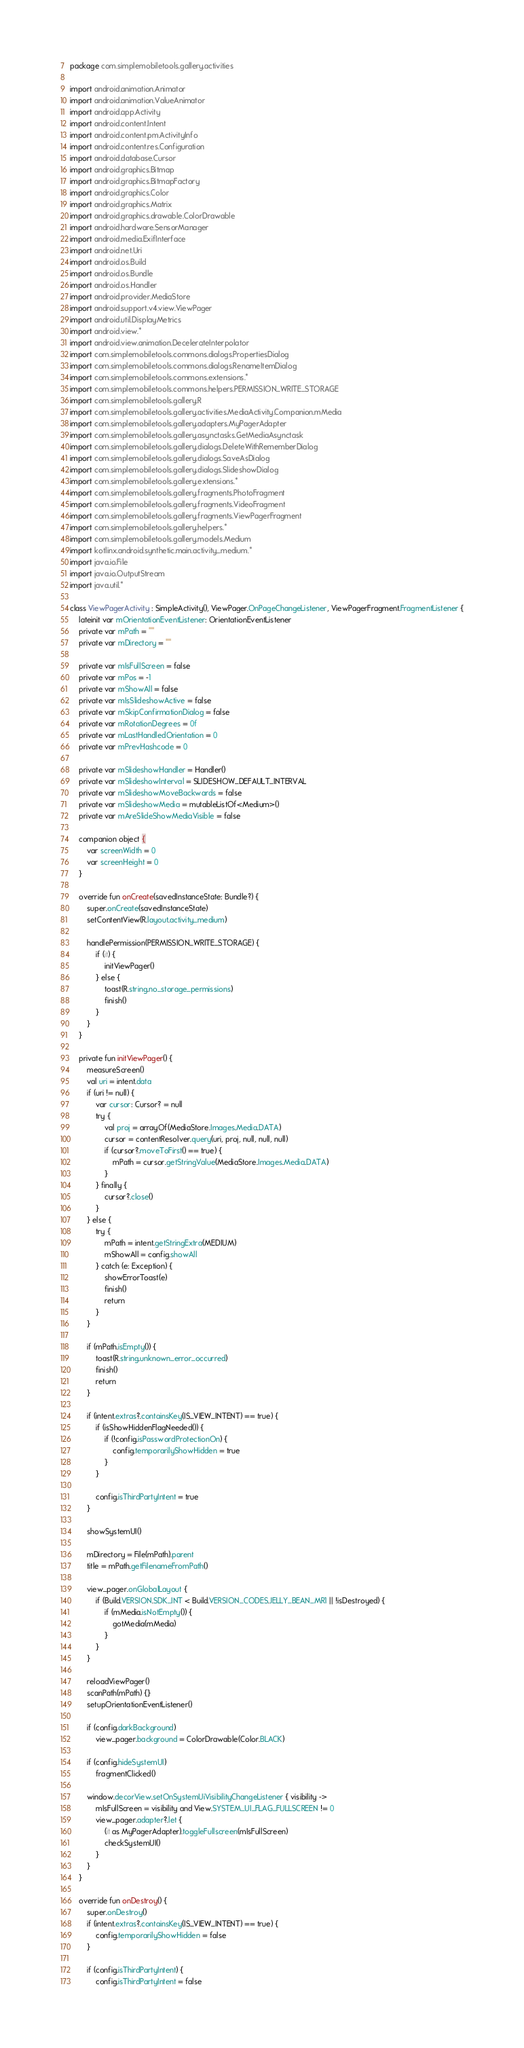Convert code to text. <code><loc_0><loc_0><loc_500><loc_500><_Kotlin_>package com.simplemobiletools.gallery.activities

import android.animation.Animator
import android.animation.ValueAnimator
import android.app.Activity
import android.content.Intent
import android.content.pm.ActivityInfo
import android.content.res.Configuration
import android.database.Cursor
import android.graphics.Bitmap
import android.graphics.BitmapFactory
import android.graphics.Color
import android.graphics.Matrix
import android.graphics.drawable.ColorDrawable
import android.hardware.SensorManager
import android.media.ExifInterface
import android.net.Uri
import android.os.Build
import android.os.Bundle
import android.os.Handler
import android.provider.MediaStore
import android.support.v4.view.ViewPager
import android.util.DisplayMetrics
import android.view.*
import android.view.animation.DecelerateInterpolator
import com.simplemobiletools.commons.dialogs.PropertiesDialog
import com.simplemobiletools.commons.dialogs.RenameItemDialog
import com.simplemobiletools.commons.extensions.*
import com.simplemobiletools.commons.helpers.PERMISSION_WRITE_STORAGE
import com.simplemobiletools.gallery.R
import com.simplemobiletools.gallery.activities.MediaActivity.Companion.mMedia
import com.simplemobiletools.gallery.adapters.MyPagerAdapter
import com.simplemobiletools.gallery.asynctasks.GetMediaAsynctask
import com.simplemobiletools.gallery.dialogs.DeleteWithRememberDialog
import com.simplemobiletools.gallery.dialogs.SaveAsDialog
import com.simplemobiletools.gallery.dialogs.SlideshowDialog
import com.simplemobiletools.gallery.extensions.*
import com.simplemobiletools.gallery.fragments.PhotoFragment
import com.simplemobiletools.gallery.fragments.VideoFragment
import com.simplemobiletools.gallery.fragments.ViewPagerFragment
import com.simplemobiletools.gallery.helpers.*
import com.simplemobiletools.gallery.models.Medium
import kotlinx.android.synthetic.main.activity_medium.*
import java.io.File
import java.io.OutputStream
import java.util.*

class ViewPagerActivity : SimpleActivity(), ViewPager.OnPageChangeListener, ViewPagerFragment.FragmentListener {
    lateinit var mOrientationEventListener: OrientationEventListener
    private var mPath = ""
    private var mDirectory = ""

    private var mIsFullScreen = false
    private var mPos = -1
    private var mShowAll = false
    private var mIsSlideshowActive = false
    private var mSkipConfirmationDialog = false
    private var mRotationDegrees = 0f
    private var mLastHandledOrientation = 0
    private var mPrevHashcode = 0

    private var mSlideshowHandler = Handler()
    private var mSlideshowInterval = SLIDESHOW_DEFAULT_INTERVAL
    private var mSlideshowMoveBackwards = false
    private var mSlideshowMedia = mutableListOf<Medium>()
    private var mAreSlideShowMediaVisible = false

    companion object {
        var screenWidth = 0
        var screenHeight = 0
    }

    override fun onCreate(savedInstanceState: Bundle?) {
        super.onCreate(savedInstanceState)
        setContentView(R.layout.activity_medium)

        handlePermission(PERMISSION_WRITE_STORAGE) {
            if (it) {
                initViewPager()
            } else {
                toast(R.string.no_storage_permissions)
                finish()
            }
        }
    }

    private fun initViewPager() {
        measureScreen()
        val uri = intent.data
        if (uri != null) {
            var cursor: Cursor? = null
            try {
                val proj = arrayOf(MediaStore.Images.Media.DATA)
                cursor = contentResolver.query(uri, proj, null, null, null)
                if (cursor?.moveToFirst() == true) {
                    mPath = cursor.getStringValue(MediaStore.Images.Media.DATA)
                }
            } finally {
                cursor?.close()
            }
        } else {
            try {
                mPath = intent.getStringExtra(MEDIUM)
                mShowAll = config.showAll
            } catch (e: Exception) {
                showErrorToast(e)
                finish()
                return
            }
        }

        if (mPath.isEmpty()) {
            toast(R.string.unknown_error_occurred)
            finish()
            return
        }

        if (intent.extras?.containsKey(IS_VIEW_INTENT) == true) {
            if (isShowHiddenFlagNeeded()) {
                if (!config.isPasswordProtectionOn) {
                    config.temporarilyShowHidden = true
                }
            }

            config.isThirdPartyIntent = true
        }

        showSystemUI()

        mDirectory = File(mPath).parent
        title = mPath.getFilenameFromPath()

        view_pager.onGlobalLayout {
            if (Build.VERSION.SDK_INT < Build.VERSION_CODES.JELLY_BEAN_MR1 || !isDestroyed) {
                if (mMedia.isNotEmpty()) {
                    gotMedia(mMedia)
                }
            }
        }

        reloadViewPager()
        scanPath(mPath) {}
        setupOrientationEventListener()

        if (config.darkBackground)
            view_pager.background = ColorDrawable(Color.BLACK)

        if (config.hideSystemUI)
            fragmentClicked()

        window.decorView.setOnSystemUiVisibilityChangeListener { visibility ->
            mIsFullScreen = visibility and View.SYSTEM_UI_FLAG_FULLSCREEN != 0
            view_pager.adapter?.let {
                (it as MyPagerAdapter).toggleFullscreen(mIsFullScreen)
                checkSystemUI()
            }
        }
    }

    override fun onDestroy() {
        super.onDestroy()
        if (intent.extras?.containsKey(IS_VIEW_INTENT) == true) {
            config.temporarilyShowHidden = false
        }

        if (config.isThirdPartyIntent) {
            config.isThirdPartyIntent = false
</code> 